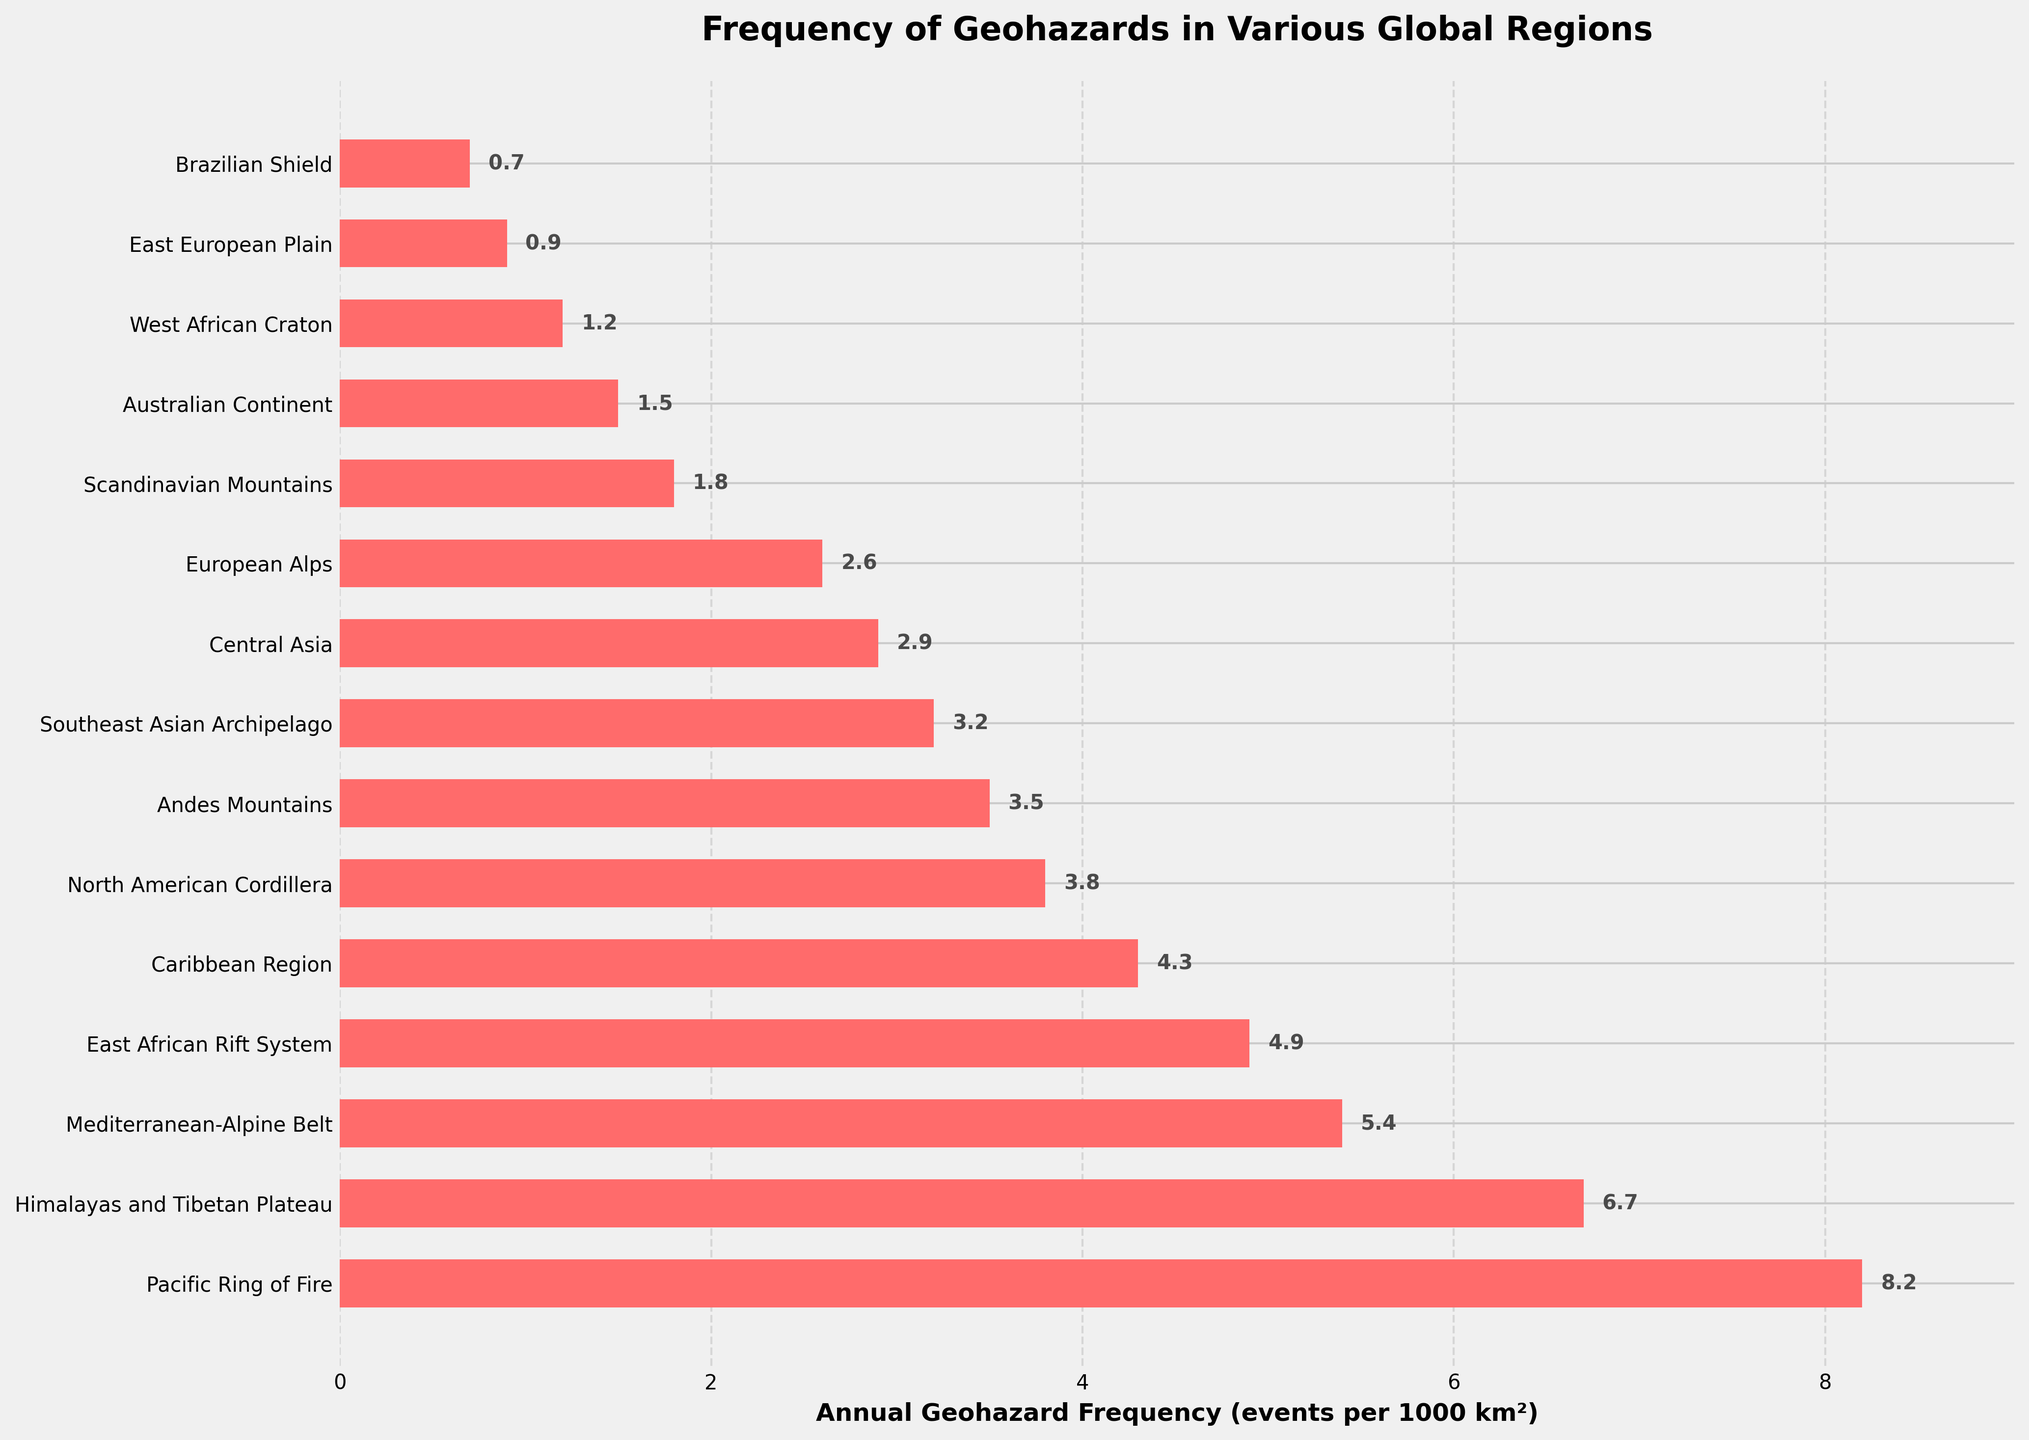What region has the highest annual geohazard frequency? By looking at the lengths of the bars in the figure, the Pacific Ring of Fire stands out as having the highest annual geohazard frequency. This is indicated by it being the longest bar.
Answer: Pacific Ring of Fire Compare the annual geohazard frequencies between the East African Rift System and the Scandinavian Mountains. Which has a higher frequency and by how much? The East African Rift System has a frequency of 4.9, and the Scandinavian Mountains have 1.8. The difference is calculated by subtracting 1.8 from 4.9, resulting in 3.1.
Answer: East African Rift System, 3.1 What is the combined annual geohazard frequency of the Mediterranean-Alpine Belt and the North American Cordillera? The figure shows the Mediterranean-Alpine Belt with a frequency of 5.4 and the North American Cordillera with 3.8. Adding these values gives 5.4 + 3.8 = 9.2.
Answer: 9.2 Which region has a higher annual geohazard frequency: the European Alps or the Andes Mountains? The figure depicts the Andes Mountains with a frequency of 3.5 and the European Alps with 2.6. Comparing these values, 3.5 is greater than 2.6.
Answer: Andes Mountains What is the total annual geohazard frequency for the regions in Europe? The European regions include the Mediterranean-Alpine Belt (5.4), European Alps (2.6), and Scandinavian Mountains (1.8). Summing these values gives 5.4 + 2.6 + 1.8 = 9.8.
Answer: 9.8 Which regions have an annual geohazard frequency less than 2 events per 1000 km²? The figure shows that the Scandinavian Mountains, Australian Continent, West African Craton, East European Plain, and Brazilian Shield all have frequencies less than 2.
Answer: Scandinavian Mountains, Australian Continent, West African Craton, East European Plain, Brazilian Shield How much higher is the annual geohazard frequency of the Himalayas and Tibetan Plateau compared to the Brazilian Shield? The frequency of the Himalayas and Tibetan Plateau is 6.7, and the Brazilian Shield is 0.7. The difference is 6.7 - 0.7 = 6.
Answer: 6 Which region has the lowest annual geohazard frequency? By observing the shortest bar in the figure, the Brazilian Shield appears to have the lowest annual geohazard frequency.
Answer: Brazilian Shield 